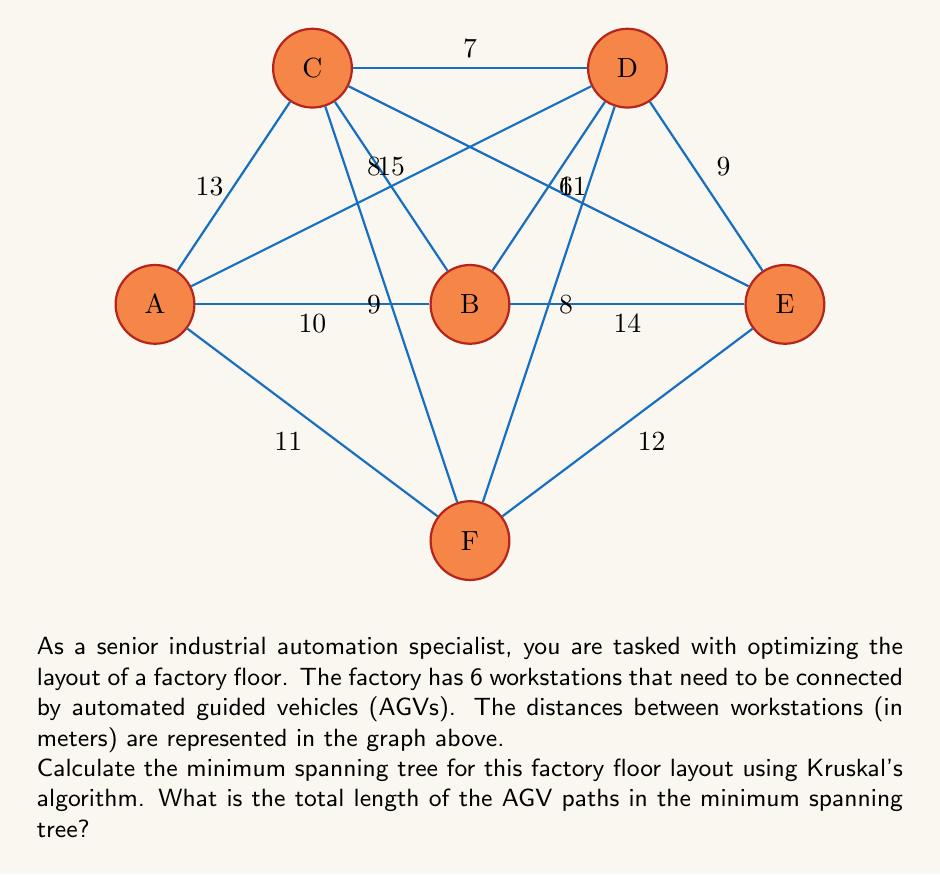Help me with this question. To solve this problem, we'll use Kruskal's algorithm to find the minimum spanning tree:

1. Sort all edges by weight (distance) in ascending order:
   B-D (6), C-D (7), B-C (8), D-F (8), A-B (10), C-F (9), D-E (9), A-F (11), C-E (11), A-C (13), B-E (14), A-D (15)

2. Start with an empty set of edges and add edges in order, skipping those that would create a cycle:

   - Add B-D (6)
   - Add C-D (7)
   - Add B-C (8) - skip, would create a cycle
   - Add D-F (8)
   - Add A-B (10)
   - Add C-F (9) - skip, would create a cycle
   - Add D-E (9)

3. We now have 5 edges, which is sufficient for a minimum spanning tree of 6 vertices.

4. The selected edges are:
   B-D (6), C-D (7), D-F (8), A-B (10), D-E (9)

5. Calculate the total length:
   $$6 + 7 + 8 + 10 + 9 = 40$$

Therefore, the minimum spanning tree has a total length of 40 meters.
Answer: 40 meters 